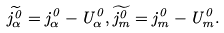<formula> <loc_0><loc_0><loc_500><loc_500>\widetilde { j _ { \alpha } ^ { 0 } } = j _ { \alpha } ^ { 0 } - U _ { \alpha } ^ { 0 } , \widetilde { j _ { m } ^ { 0 } } = j _ { m } ^ { 0 } - U _ { m } ^ { 0 } .</formula> 